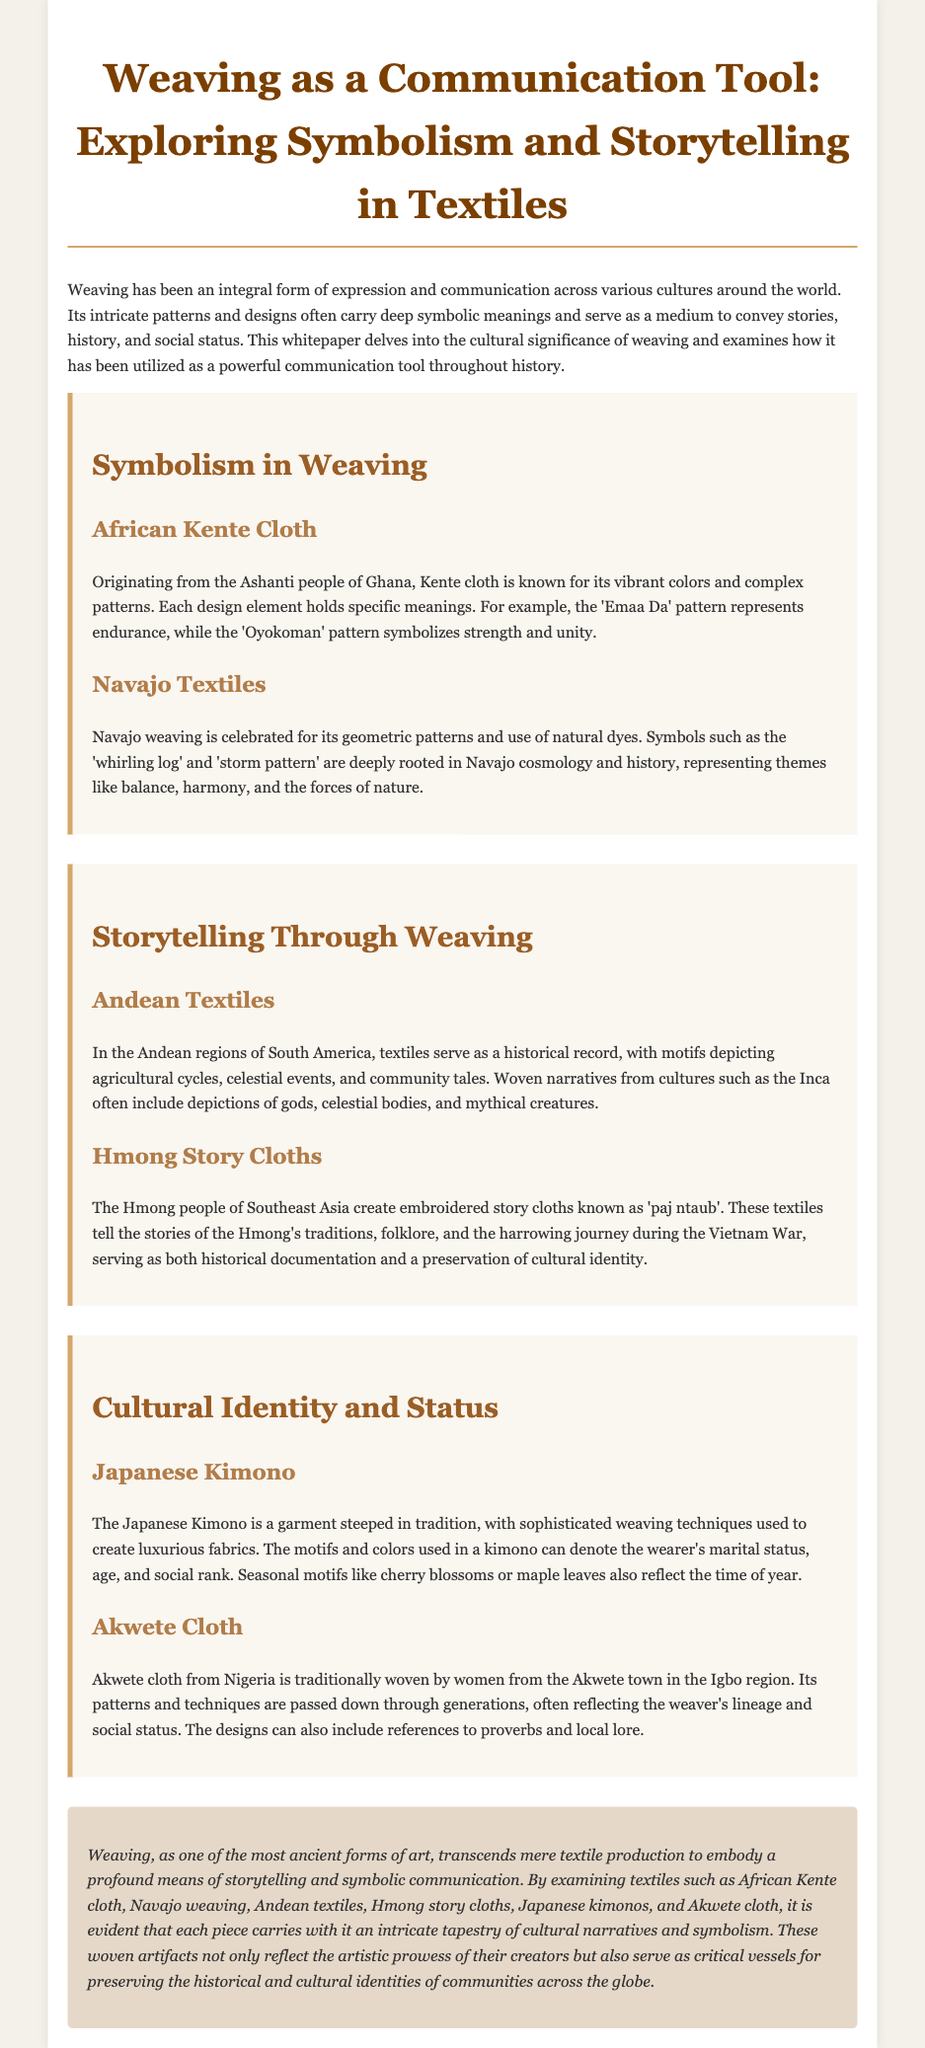what is the title of the whitepaper? The title is presented in the header of the document and is "Weaving as a Communication Tool: Exploring Symbolism and Storytelling in Textiles."
Answer: Weaving as a Communication Tool: Exploring Symbolism and Storytelling in Textiles which culture is associated with Kente cloth? Kente cloth originates from a specific group of people mentioned in the document, which are the Ashanti people of Ghana.
Answer: Ashanti what does the 'Emaa Da' pattern represent? The document provides a specific meaning associated with the 'Emaa Da' pattern, which is endurance.
Answer: endurance which two themes are represented in Navajo textiles? The document specifies the themes represented in Navajo textiles include balance and harmony, along with the forces of nature.
Answer: balance, harmony what do Andean textiles depict? The document lists various motifs depicted in Andean textiles, highlighting that they serve as a historical record.
Answer: agricultural cycles, celestial events, community tales how do motifs in a Japanese kimono reflect social status? The document explains that motifs and colors in kimonos can denote various aspects related to the wearer's social rank.
Answer: marital status, age, social rank which textile tradition is associated with the Hmong people's history during the Vietnam War? The document mentions a specific type of textile that tells the stories related to the Hmong's journey during this period.
Answer: paj ntaub what represents the weaver's lineage in Akwete cloth? The document indicates that patterns and techniques in Akwete cloth reflect a specific aspect related to the weaver.
Answer: lineage what is the conclusion regarding weaving as an art form? The conclusion summarizes the role of weaving, emphasizing its significance as a means of storytelling and communication.
Answer: storytelling and symbolic communication 